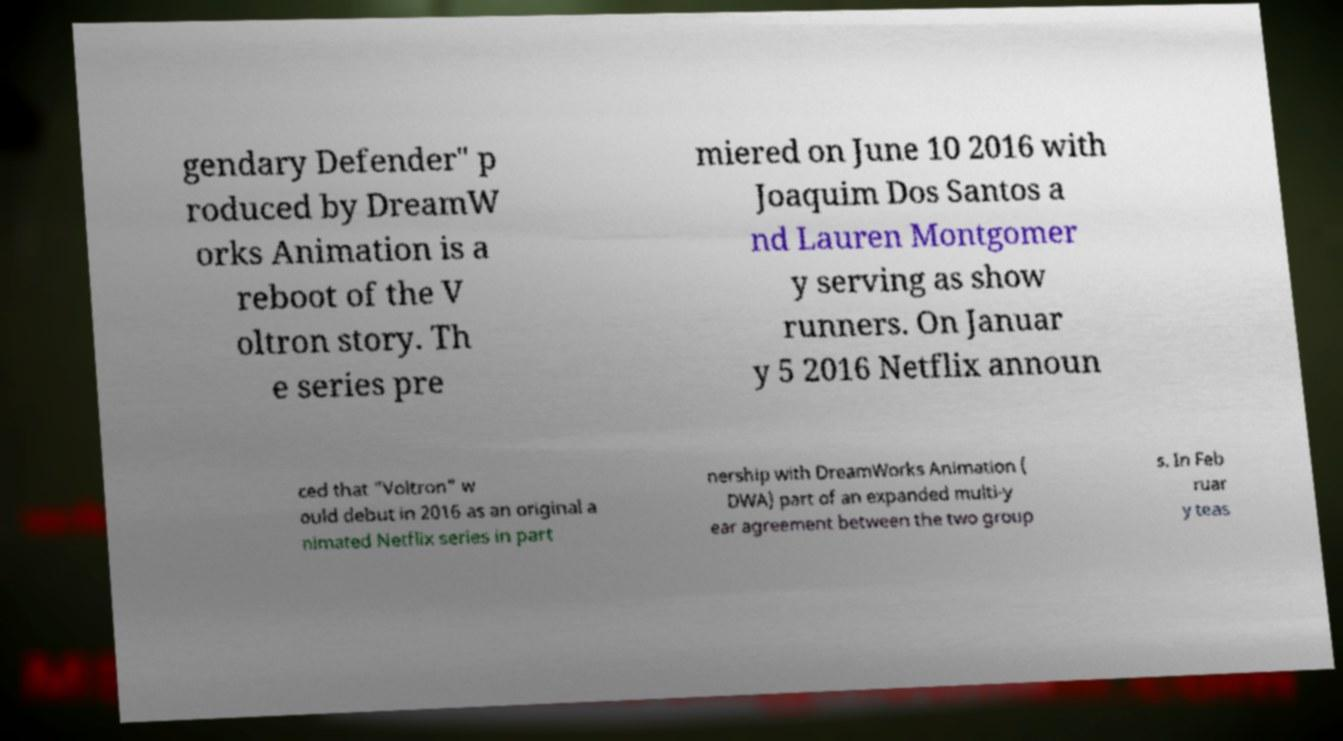Can you accurately transcribe the text from the provided image for me? gendary Defender" p roduced by DreamW orks Animation is a reboot of the V oltron story. Th e series pre miered on June 10 2016 with Joaquim Dos Santos a nd Lauren Montgomer y serving as show runners. On Januar y 5 2016 Netflix announ ced that "Voltron" w ould debut in 2016 as an original a nimated Netflix series in part nership with DreamWorks Animation ( DWA) part of an expanded multi-y ear agreement between the two group s. In Feb ruar y teas 